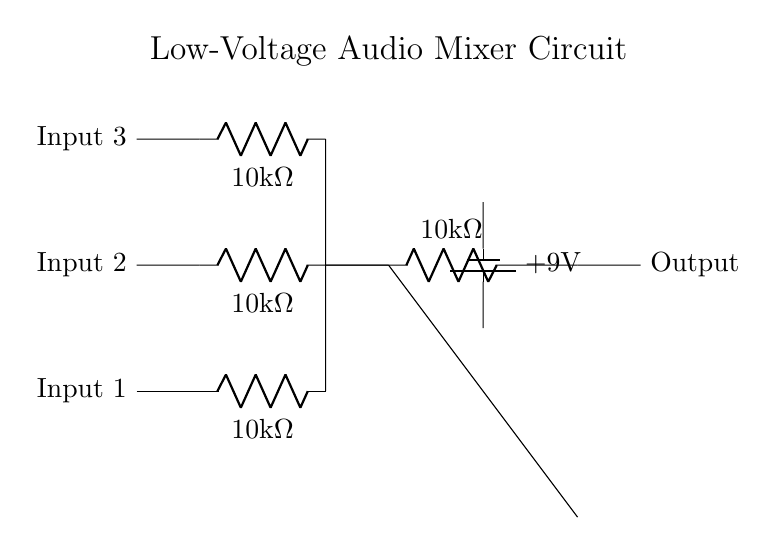What is the total resistance of the input resistors? The total resistance is calculated by summing the individual resistances since they are in parallel. The formula for resistors in parallel is 1/R_total = 1/R1 + 1/R2 + 1/R3. With R1, R2, and R3 all being 10k Ohms, we find R_total = 10k Ohm / 3 = 3.33k Ohm.
Answer: 3.33k Ohm What type of component is used for mixing the signals? The component used for mixing the signals is an operational amplifier (op-amp). It combines the inputs and amplifies the resulting signal in the circuit.
Answer: op-amp What is the supply voltage for the circuit? The power supply voltage is indicated on the battery symbol in the circuit, which shows a voltage of +9V. This provides the necessary power for the components in the mixer.
Answer: +9V How many input channels are present in this mixer circuit? The circuit has three input channels, as indicated by the three separate lines leading to different resistors before the summing point.
Answer: 3 What is the value of the feedback resistor? The value of the feedback resistor Rf is labeled in the diagram, showing it to be 10k Ohms, which is crucial for determining the gain of the operational amplifier.
Answer: 10k Ohm What is the purpose of the input resistors? The input resistors limit the current from each instrument input to the mixer circuit. They help to prevent overload and maintain signal integrity while ensuring proper mixing.
Answer: current limiting 